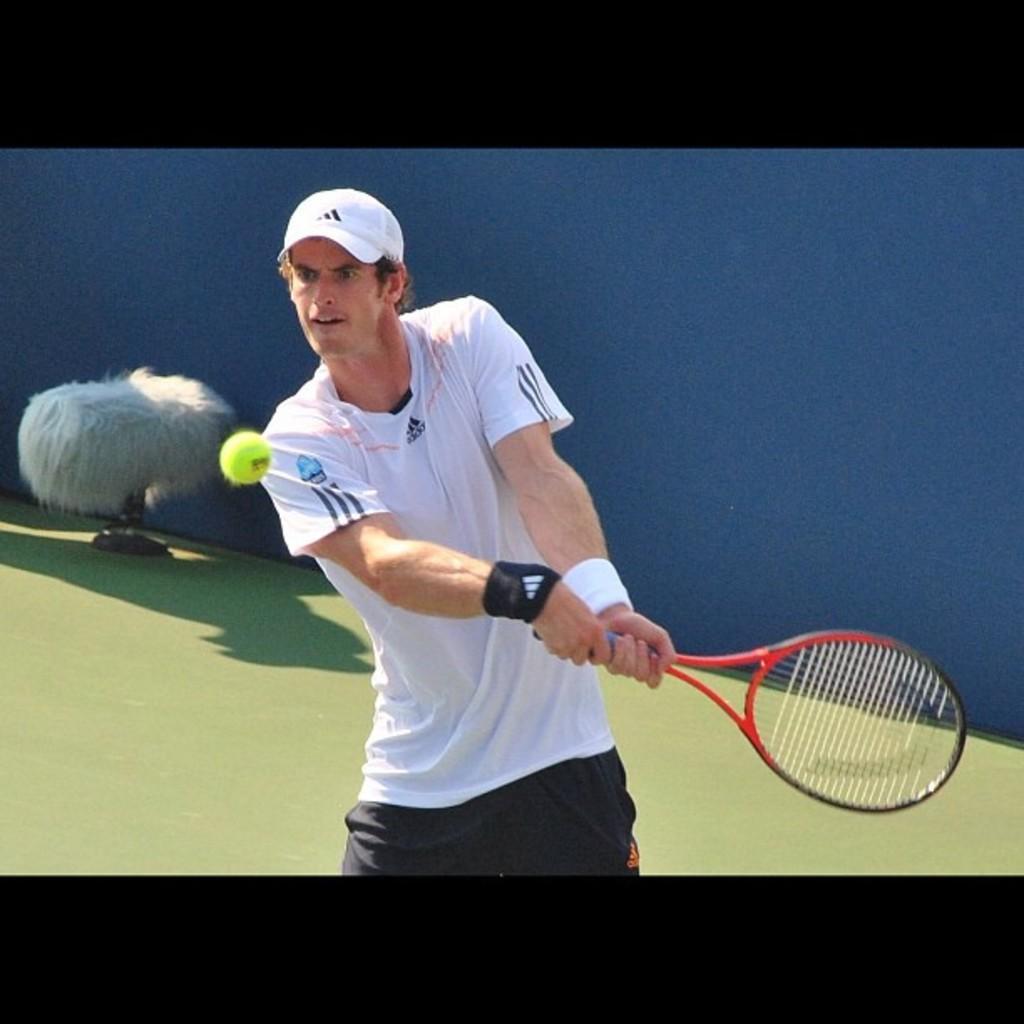In one or two sentences, can you explain what this image depicts? In this picture we can see a person holding a tennis racket in his hands. There is a ball in the air. We can see a white object in the background. 